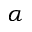Convert formula to latex. <formula><loc_0><loc_0><loc_500><loc_500>\alpha</formula> 